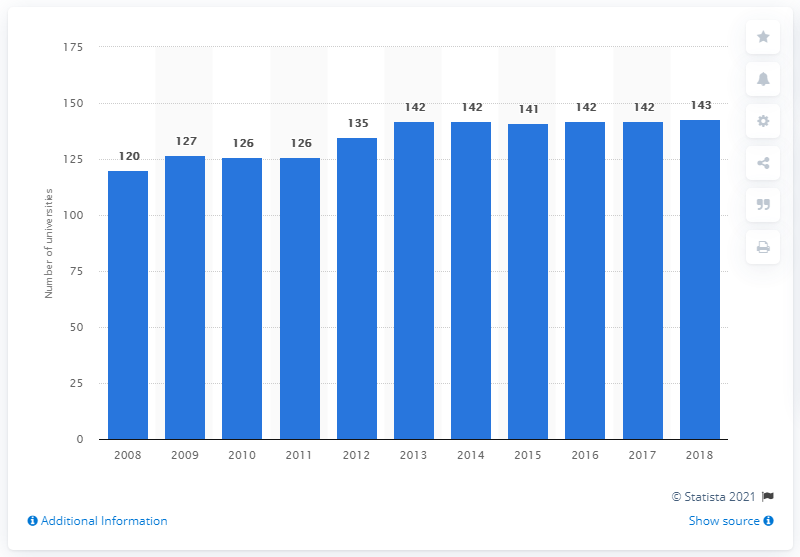Mention a couple of crucial points in this snapshot. There were 142 universities in the UK in 2018. 